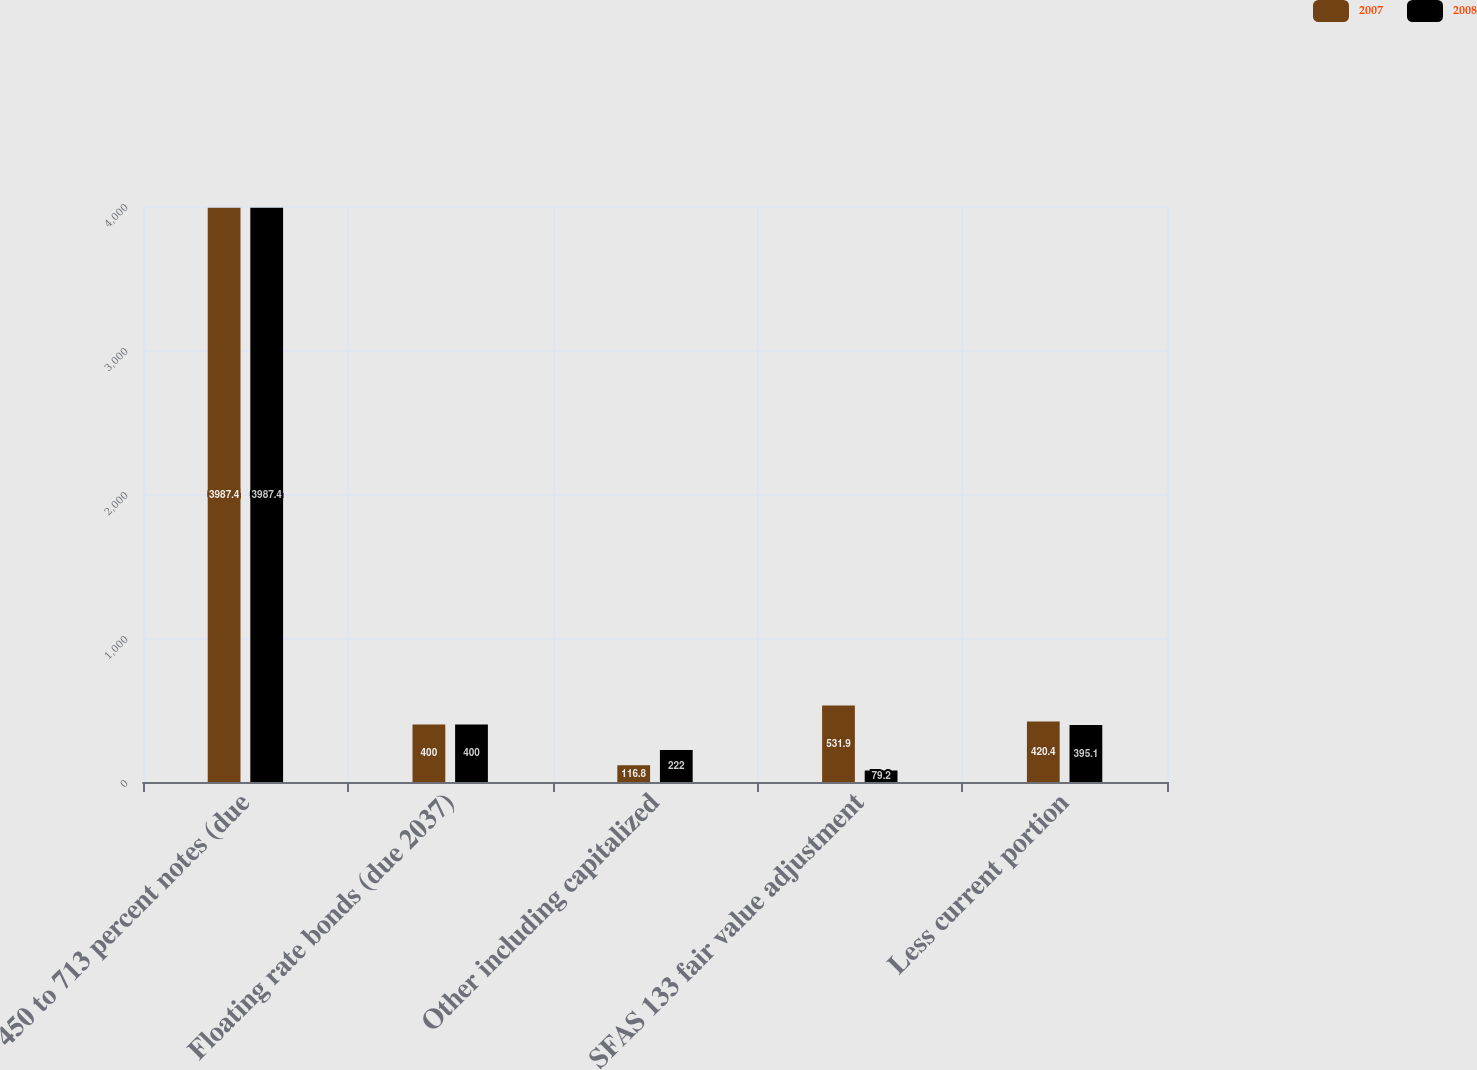Convert chart to OTSL. <chart><loc_0><loc_0><loc_500><loc_500><stacked_bar_chart><ecel><fcel>450 to 713 percent notes (due<fcel>Floating rate bonds (due 2037)<fcel>Other including capitalized<fcel>SFAS 133 fair value adjustment<fcel>Less current portion<nl><fcel>2007<fcel>3987.4<fcel>400<fcel>116.8<fcel>531.9<fcel>420.4<nl><fcel>2008<fcel>3987.4<fcel>400<fcel>222<fcel>79.2<fcel>395.1<nl></chart> 